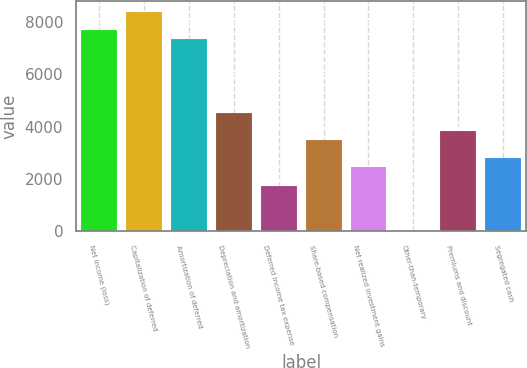<chart> <loc_0><loc_0><loc_500><loc_500><bar_chart><fcel>Net income (loss)<fcel>Capitalization of deferred<fcel>Amortization of deferred<fcel>Depreciation and amortization<fcel>Deferred income tax expense<fcel>Share-based compensation<fcel>Net realized investment gains<fcel>Other-than-temporary<fcel>Premiums and discount<fcel>Segregated cash<nl><fcel>7668.8<fcel>8365.6<fcel>7320.4<fcel>4533.2<fcel>1746<fcel>3488<fcel>2442.8<fcel>4<fcel>3836.4<fcel>2791.2<nl></chart> 